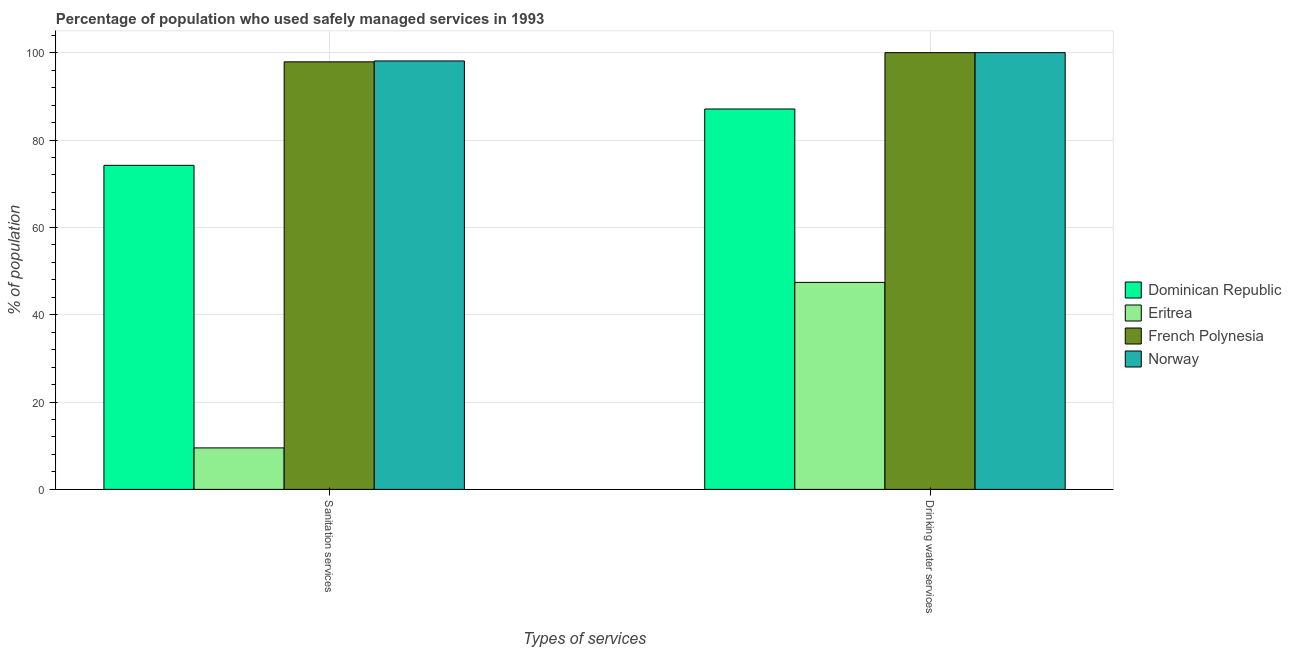How many different coloured bars are there?
Offer a terse response. 4. Are the number of bars per tick equal to the number of legend labels?
Provide a succinct answer. Yes. Are the number of bars on each tick of the X-axis equal?
Your answer should be very brief. Yes. How many bars are there on the 2nd tick from the left?
Your answer should be very brief. 4. How many bars are there on the 1st tick from the right?
Provide a succinct answer. 4. What is the label of the 2nd group of bars from the left?
Offer a very short reply. Drinking water services. Across all countries, what is the maximum percentage of population who used sanitation services?
Offer a terse response. 98.1. Across all countries, what is the minimum percentage of population who used sanitation services?
Offer a very short reply. 9.5. In which country was the percentage of population who used sanitation services maximum?
Give a very brief answer. Norway. In which country was the percentage of population who used drinking water services minimum?
Make the answer very short. Eritrea. What is the total percentage of population who used sanitation services in the graph?
Provide a succinct answer. 279.7. What is the difference between the percentage of population who used sanitation services in Eritrea and that in French Polynesia?
Your response must be concise. -88.4. What is the difference between the percentage of population who used sanitation services in Norway and the percentage of population who used drinking water services in French Polynesia?
Offer a very short reply. -1.9. What is the average percentage of population who used sanitation services per country?
Your answer should be very brief. 69.93. What is the difference between the percentage of population who used drinking water services and percentage of population who used sanitation services in Dominican Republic?
Provide a succinct answer. 12.9. In how many countries, is the percentage of population who used sanitation services greater than 4 %?
Keep it short and to the point. 4. What is the ratio of the percentage of population who used sanitation services in Eritrea to that in French Polynesia?
Keep it short and to the point. 0.1. Is the percentage of population who used drinking water services in Norway less than that in Eritrea?
Provide a short and direct response. No. What does the 3rd bar from the right in Sanitation services represents?
Keep it short and to the point. Eritrea. Does the graph contain any zero values?
Keep it short and to the point. No. Does the graph contain grids?
Offer a very short reply. Yes. Where does the legend appear in the graph?
Your answer should be very brief. Center right. How many legend labels are there?
Ensure brevity in your answer.  4. How are the legend labels stacked?
Make the answer very short. Vertical. What is the title of the graph?
Your answer should be compact. Percentage of population who used safely managed services in 1993. Does "Gabon" appear as one of the legend labels in the graph?
Your answer should be compact. No. What is the label or title of the X-axis?
Make the answer very short. Types of services. What is the label or title of the Y-axis?
Your answer should be compact. % of population. What is the % of population in Dominican Republic in Sanitation services?
Give a very brief answer. 74.2. What is the % of population in French Polynesia in Sanitation services?
Provide a succinct answer. 97.9. What is the % of population in Norway in Sanitation services?
Your answer should be compact. 98.1. What is the % of population in Dominican Republic in Drinking water services?
Provide a short and direct response. 87.1. What is the % of population of Eritrea in Drinking water services?
Give a very brief answer. 47.4. Across all Types of services, what is the maximum % of population in Dominican Republic?
Provide a succinct answer. 87.1. Across all Types of services, what is the maximum % of population of Eritrea?
Give a very brief answer. 47.4. Across all Types of services, what is the minimum % of population of Dominican Republic?
Provide a succinct answer. 74.2. Across all Types of services, what is the minimum % of population in Eritrea?
Provide a succinct answer. 9.5. Across all Types of services, what is the minimum % of population in French Polynesia?
Give a very brief answer. 97.9. Across all Types of services, what is the minimum % of population in Norway?
Provide a succinct answer. 98.1. What is the total % of population in Dominican Republic in the graph?
Provide a short and direct response. 161.3. What is the total % of population of Eritrea in the graph?
Offer a terse response. 56.9. What is the total % of population of French Polynesia in the graph?
Provide a short and direct response. 197.9. What is the total % of population in Norway in the graph?
Ensure brevity in your answer.  198.1. What is the difference between the % of population of Eritrea in Sanitation services and that in Drinking water services?
Offer a terse response. -37.9. What is the difference between the % of population of Dominican Republic in Sanitation services and the % of population of Eritrea in Drinking water services?
Keep it short and to the point. 26.8. What is the difference between the % of population in Dominican Republic in Sanitation services and the % of population in French Polynesia in Drinking water services?
Keep it short and to the point. -25.8. What is the difference between the % of population in Dominican Republic in Sanitation services and the % of population in Norway in Drinking water services?
Provide a short and direct response. -25.8. What is the difference between the % of population of Eritrea in Sanitation services and the % of population of French Polynesia in Drinking water services?
Your answer should be compact. -90.5. What is the difference between the % of population of Eritrea in Sanitation services and the % of population of Norway in Drinking water services?
Ensure brevity in your answer.  -90.5. What is the difference between the % of population of French Polynesia in Sanitation services and the % of population of Norway in Drinking water services?
Your answer should be compact. -2.1. What is the average % of population in Dominican Republic per Types of services?
Your answer should be very brief. 80.65. What is the average % of population of Eritrea per Types of services?
Provide a short and direct response. 28.45. What is the average % of population in French Polynesia per Types of services?
Make the answer very short. 98.95. What is the average % of population in Norway per Types of services?
Your response must be concise. 99.05. What is the difference between the % of population of Dominican Republic and % of population of Eritrea in Sanitation services?
Offer a very short reply. 64.7. What is the difference between the % of population in Dominican Republic and % of population in French Polynesia in Sanitation services?
Your answer should be compact. -23.7. What is the difference between the % of population in Dominican Republic and % of population in Norway in Sanitation services?
Provide a succinct answer. -23.9. What is the difference between the % of population in Eritrea and % of population in French Polynesia in Sanitation services?
Your response must be concise. -88.4. What is the difference between the % of population of Eritrea and % of population of Norway in Sanitation services?
Your answer should be compact. -88.6. What is the difference between the % of population in Dominican Republic and % of population in Eritrea in Drinking water services?
Your answer should be very brief. 39.7. What is the difference between the % of population in Eritrea and % of population in French Polynesia in Drinking water services?
Ensure brevity in your answer.  -52.6. What is the difference between the % of population of Eritrea and % of population of Norway in Drinking water services?
Make the answer very short. -52.6. What is the difference between the % of population in French Polynesia and % of population in Norway in Drinking water services?
Ensure brevity in your answer.  0. What is the ratio of the % of population of Dominican Republic in Sanitation services to that in Drinking water services?
Make the answer very short. 0.85. What is the ratio of the % of population of Eritrea in Sanitation services to that in Drinking water services?
Ensure brevity in your answer.  0.2. What is the ratio of the % of population in French Polynesia in Sanitation services to that in Drinking water services?
Ensure brevity in your answer.  0.98. What is the ratio of the % of population in Norway in Sanitation services to that in Drinking water services?
Your response must be concise. 0.98. What is the difference between the highest and the second highest % of population of Dominican Republic?
Provide a succinct answer. 12.9. What is the difference between the highest and the second highest % of population in Eritrea?
Make the answer very short. 37.9. What is the difference between the highest and the lowest % of population of Eritrea?
Offer a terse response. 37.9. What is the difference between the highest and the lowest % of population in French Polynesia?
Provide a short and direct response. 2.1. 